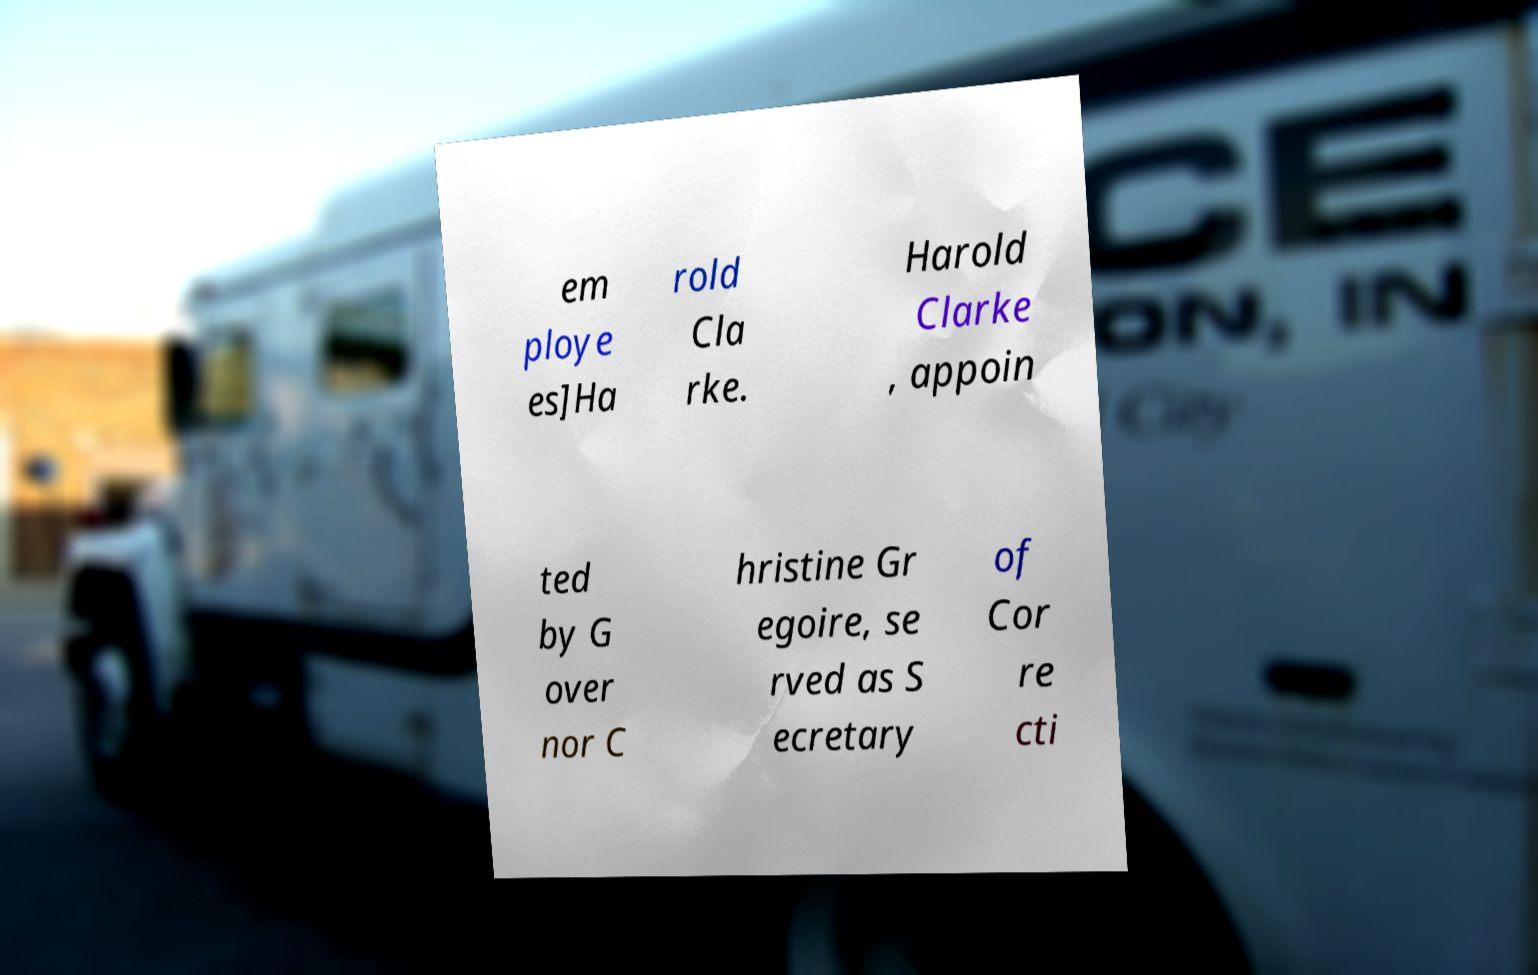Could you extract and type out the text from this image? em ploye es]Ha rold Cla rke. Harold Clarke , appoin ted by G over nor C hristine Gr egoire, se rved as S ecretary of Cor re cti 